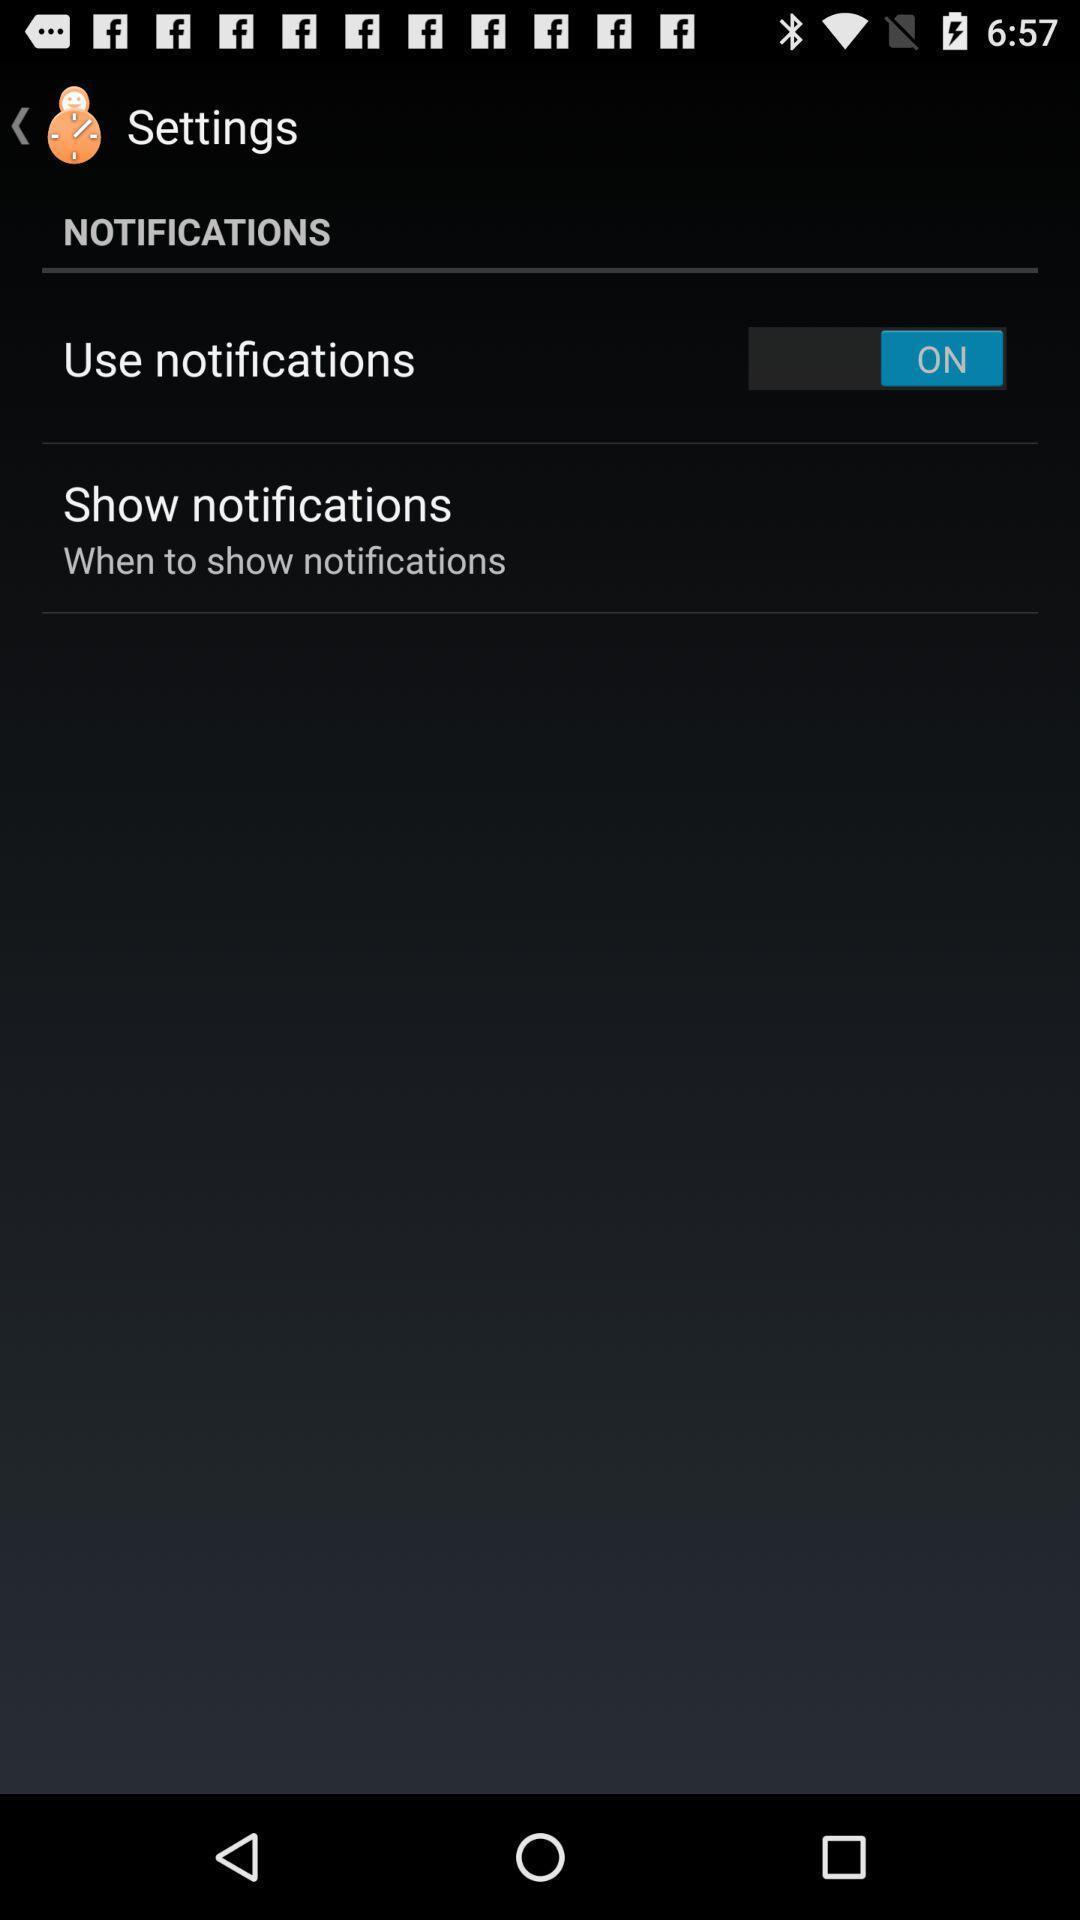Describe this image in words. Screen shows notification settings on an app. 